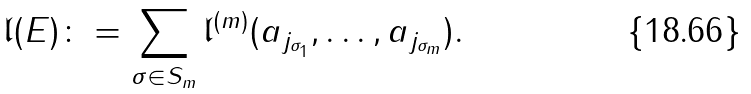Convert formula to latex. <formula><loc_0><loc_0><loc_500><loc_500>\mathfrak l ( E ) \colon = \sum _ { \sigma \in S _ { m } } \mathfrak l ^ { ( m ) } ( a _ { j _ { \sigma _ { 1 } } } , \dots , a _ { j _ { \sigma _ { m } } } ) .</formula> 